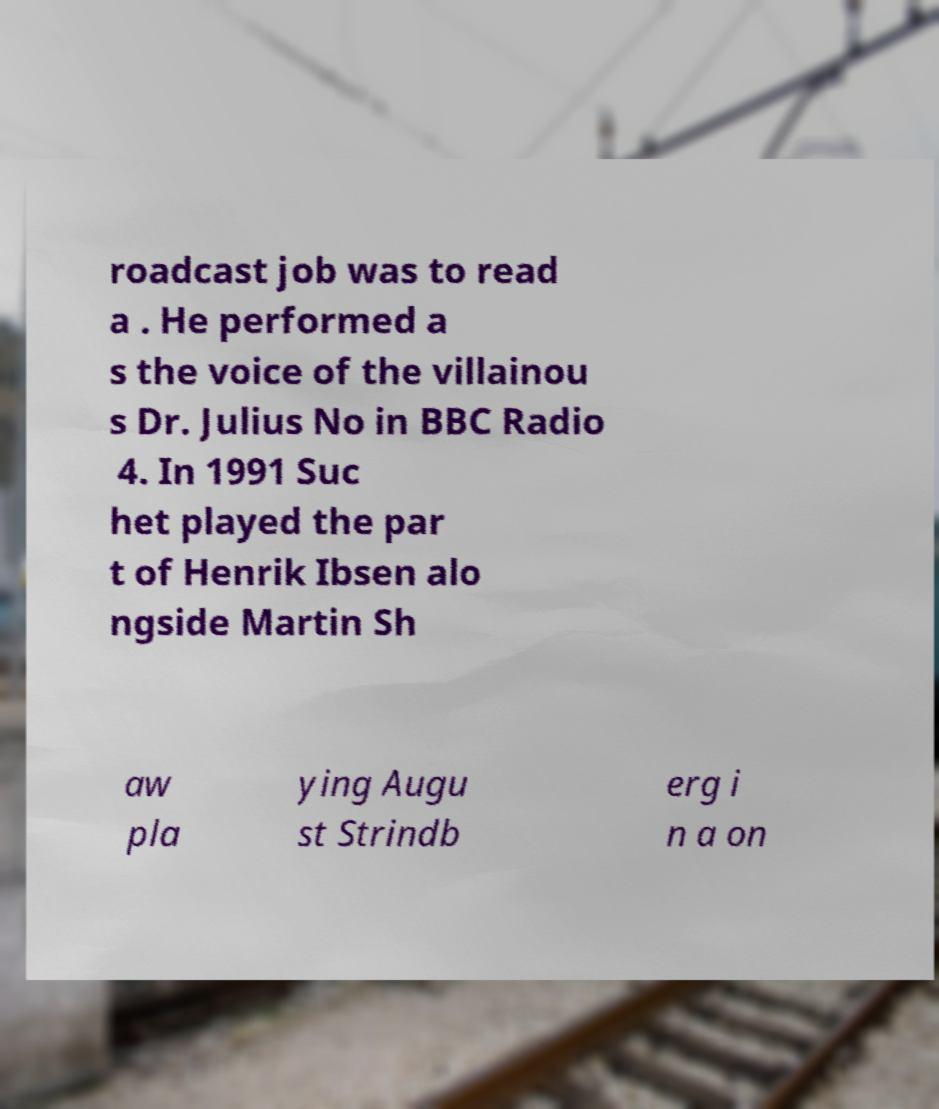I need the written content from this picture converted into text. Can you do that? roadcast job was to read a . He performed a s the voice of the villainou s Dr. Julius No in BBC Radio 4. In 1991 Suc het played the par t of Henrik Ibsen alo ngside Martin Sh aw pla ying Augu st Strindb erg i n a on 